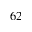Convert formula to latex. <formula><loc_0><loc_0><loc_500><loc_500>_ { 6 2 }</formula> 